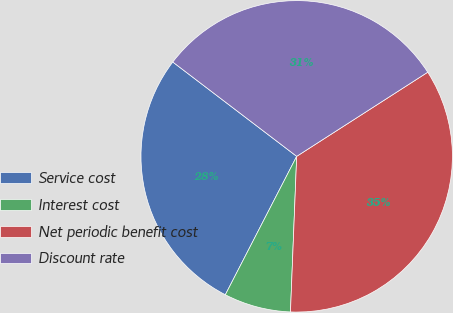Convert chart to OTSL. <chart><loc_0><loc_0><loc_500><loc_500><pie_chart><fcel>Service cost<fcel>Interest cost<fcel>Net periodic benefit cost<fcel>Discount rate<nl><fcel>27.78%<fcel>6.94%<fcel>34.72%<fcel>30.56%<nl></chart> 